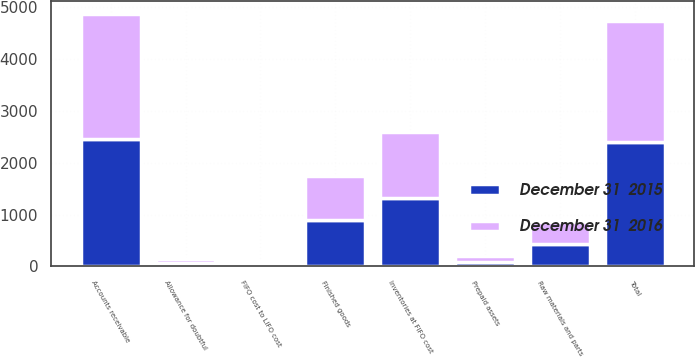Convert chart to OTSL. <chart><loc_0><loc_0><loc_500><loc_500><stacked_bar_chart><ecel><fcel>Accounts receivable<fcel>Allowance for doubtful<fcel>Total<fcel>Finished goods<fcel>Raw materials and parts<fcel>Inventories at FIFO cost<fcel>FIFO cost to LIFO cost<fcel>Prepaid assets<nl><fcel>December 31  2016<fcel>2408.8<fcel>67.6<fcel>2341.2<fcel>860<fcel>408.4<fcel>1268.4<fcel>51<fcel>98.3<nl><fcel>December 31  2015<fcel>2465.5<fcel>75.3<fcel>2390.2<fcel>886.5<fcel>440.9<fcel>1327.4<fcel>60.8<fcel>94.6<nl></chart> 